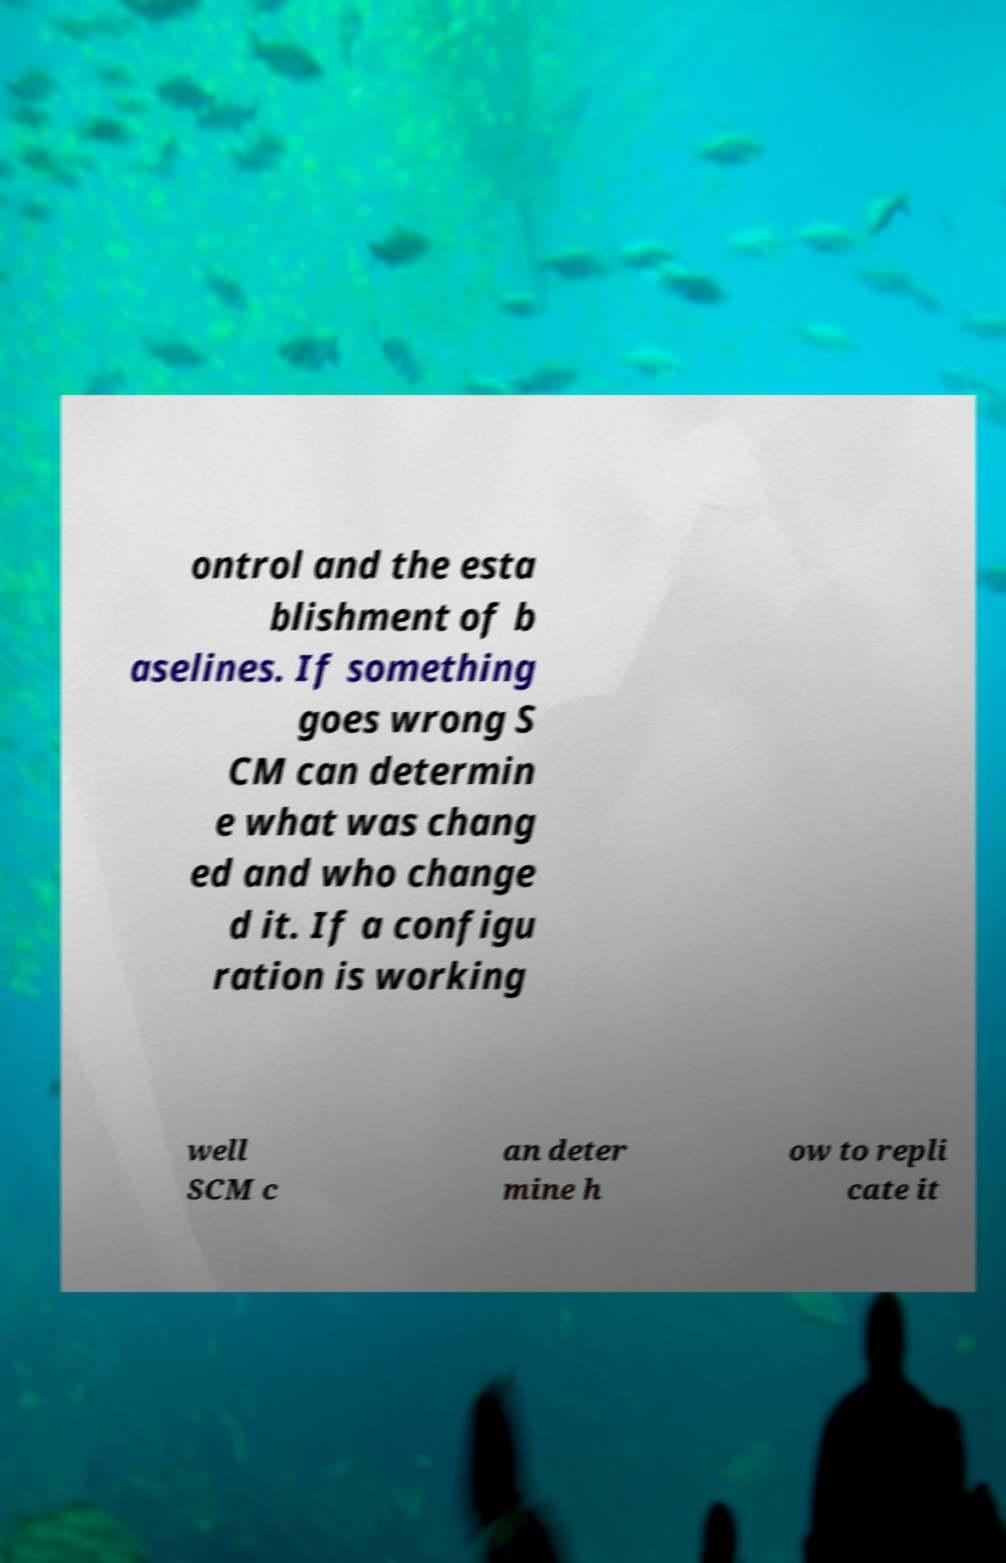What messages or text are displayed in this image? I need them in a readable, typed format. ontrol and the esta blishment of b aselines. If something goes wrong S CM can determin e what was chang ed and who change d it. If a configu ration is working well SCM c an deter mine h ow to repli cate it 